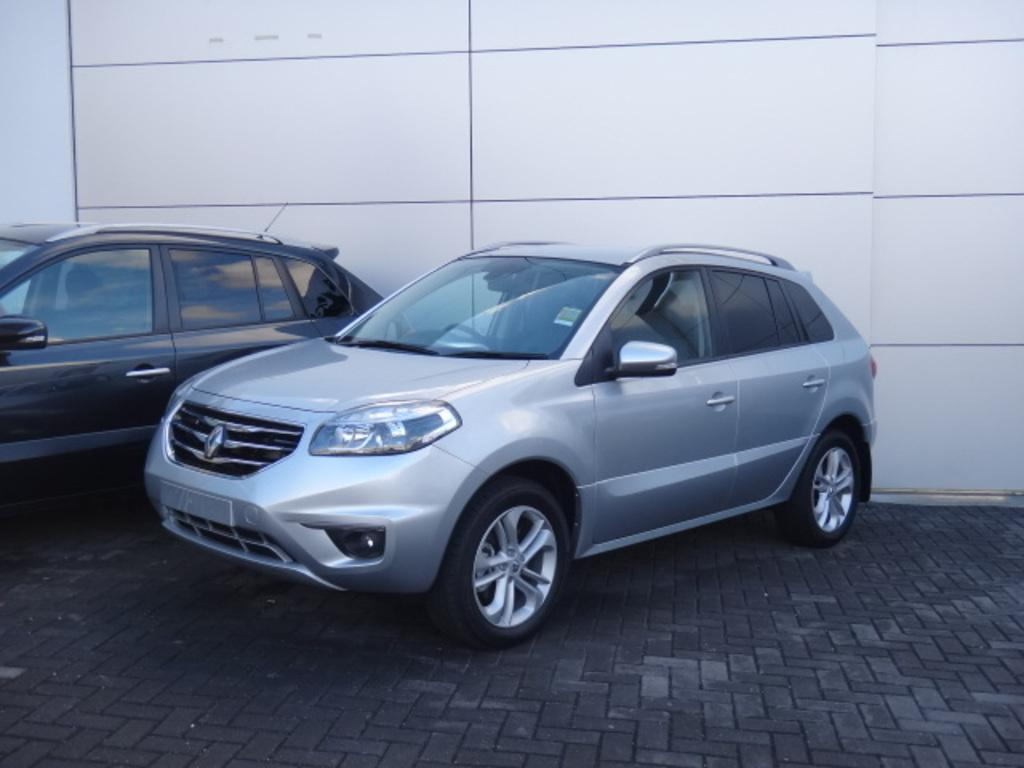How many cars are visible in the image? There are 2 cars in the image. Where are the cars located in the image? The cars are parked on a black floor. What type of background can be seen in the image? There is a white wall in the image. What degree of difficulty is required to walk on the white wall in the image? There is no indication that anyone is walking on the white wall in the image, and therefore no degree of difficulty can be determined. 